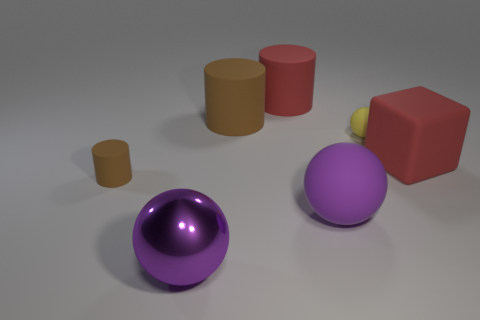There is a object on the left side of the purple thing that is to the left of the big red rubber object left of the yellow matte thing; what is its color?
Ensure brevity in your answer.  Brown. There is a cylinder that is the same size as the yellow ball; what color is it?
Keep it short and to the point. Brown. What number of rubber objects are either big purple spheres or small yellow things?
Your response must be concise. 2. There is a big ball that is the same material as the red cylinder; what color is it?
Offer a very short reply. Purple. There is a small thing that is to the right of the brown cylinder behind the red rubber block; what is its material?
Your response must be concise. Rubber. What number of things are either brown objects in front of the large brown matte cylinder or brown cylinders that are on the right side of the big metal ball?
Ensure brevity in your answer.  2. There is a brown matte thing behind the large block to the right of the tiny brown matte thing that is on the left side of the yellow thing; what size is it?
Offer a terse response. Large. Is the number of metallic balls behind the big red cube the same as the number of large red things?
Give a very brief answer. No. There is a big purple metal object; is its shape the same as the tiny thing that is right of the big purple rubber thing?
Make the answer very short. Yes. What is the size of the other brown matte object that is the same shape as the large brown rubber object?
Your answer should be very brief. Small. 